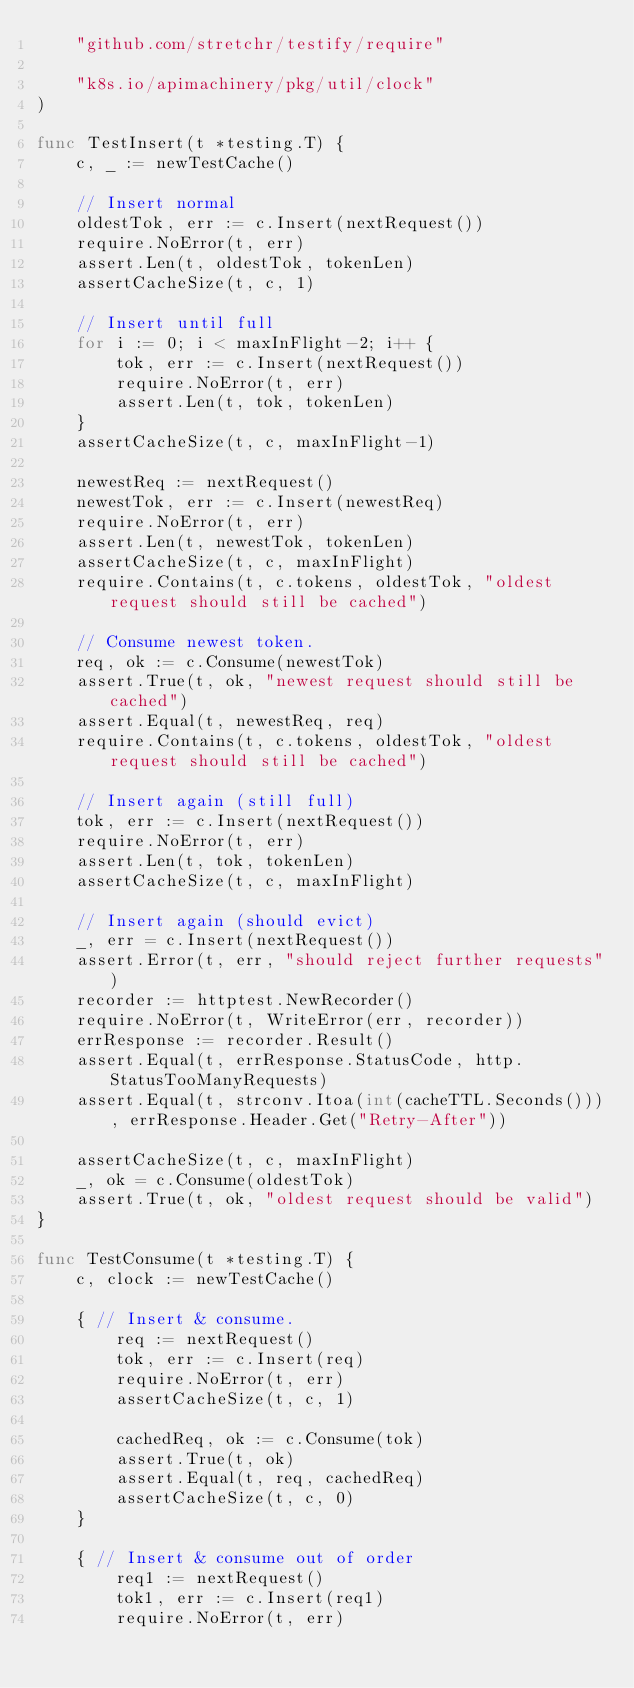<code> <loc_0><loc_0><loc_500><loc_500><_Go_>	"github.com/stretchr/testify/require"

	"k8s.io/apimachinery/pkg/util/clock"
)

func TestInsert(t *testing.T) {
	c, _ := newTestCache()

	// Insert normal
	oldestTok, err := c.Insert(nextRequest())
	require.NoError(t, err)
	assert.Len(t, oldestTok, tokenLen)
	assertCacheSize(t, c, 1)

	// Insert until full
	for i := 0; i < maxInFlight-2; i++ {
		tok, err := c.Insert(nextRequest())
		require.NoError(t, err)
		assert.Len(t, tok, tokenLen)
	}
	assertCacheSize(t, c, maxInFlight-1)

	newestReq := nextRequest()
	newestTok, err := c.Insert(newestReq)
	require.NoError(t, err)
	assert.Len(t, newestTok, tokenLen)
	assertCacheSize(t, c, maxInFlight)
	require.Contains(t, c.tokens, oldestTok, "oldest request should still be cached")

	// Consume newest token.
	req, ok := c.Consume(newestTok)
	assert.True(t, ok, "newest request should still be cached")
	assert.Equal(t, newestReq, req)
	require.Contains(t, c.tokens, oldestTok, "oldest request should still be cached")

	// Insert again (still full)
	tok, err := c.Insert(nextRequest())
	require.NoError(t, err)
	assert.Len(t, tok, tokenLen)
	assertCacheSize(t, c, maxInFlight)

	// Insert again (should evict)
	_, err = c.Insert(nextRequest())
	assert.Error(t, err, "should reject further requests")
	recorder := httptest.NewRecorder()
	require.NoError(t, WriteError(err, recorder))
	errResponse := recorder.Result()
	assert.Equal(t, errResponse.StatusCode, http.StatusTooManyRequests)
	assert.Equal(t, strconv.Itoa(int(cacheTTL.Seconds())), errResponse.Header.Get("Retry-After"))

	assertCacheSize(t, c, maxInFlight)
	_, ok = c.Consume(oldestTok)
	assert.True(t, ok, "oldest request should be valid")
}

func TestConsume(t *testing.T) {
	c, clock := newTestCache()

	{ // Insert & consume.
		req := nextRequest()
		tok, err := c.Insert(req)
		require.NoError(t, err)
		assertCacheSize(t, c, 1)

		cachedReq, ok := c.Consume(tok)
		assert.True(t, ok)
		assert.Equal(t, req, cachedReq)
		assertCacheSize(t, c, 0)
	}

	{ // Insert & consume out of order
		req1 := nextRequest()
		tok1, err := c.Insert(req1)
		require.NoError(t, err)</code> 